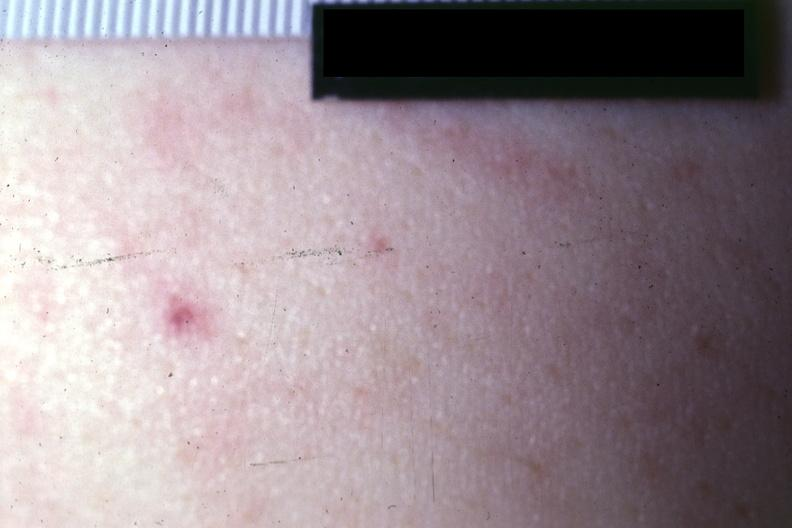s glomerulosa present?
Answer the question using a single word or phrase. No 